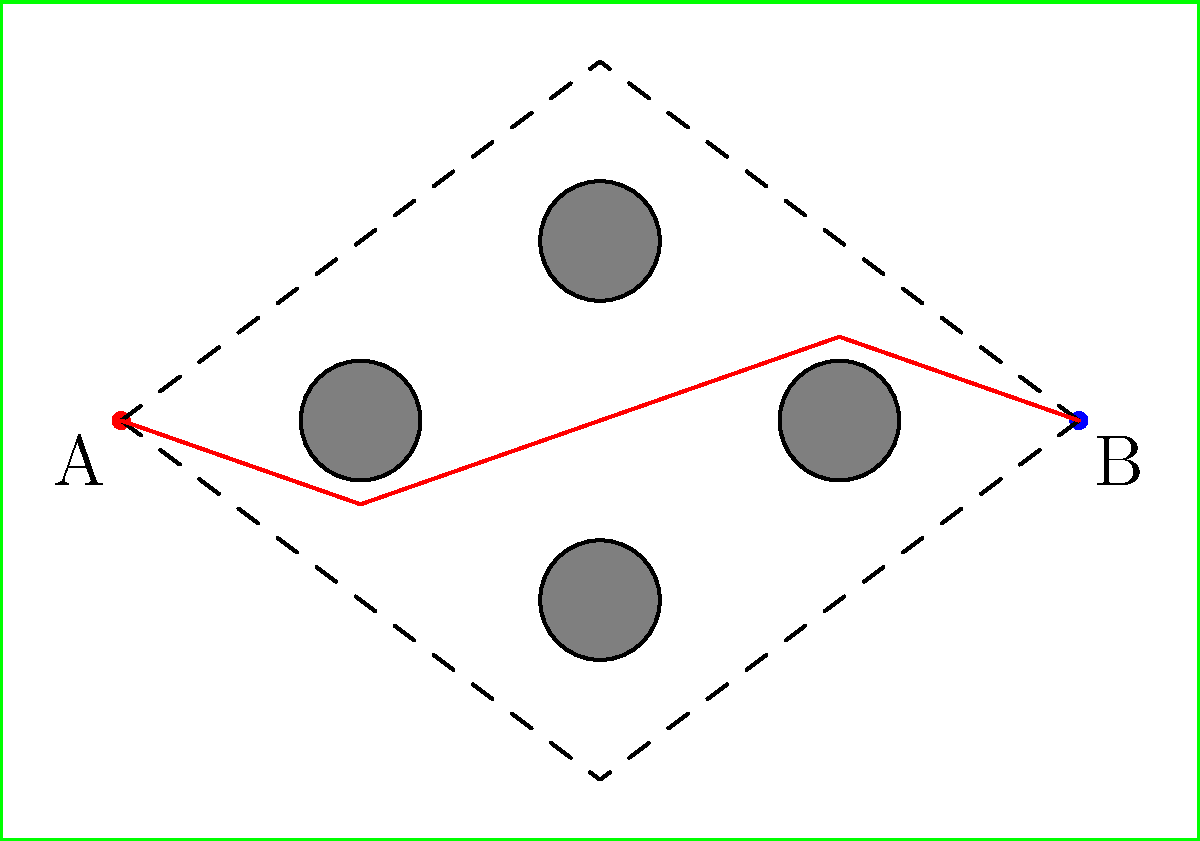On a rugby field, you need to find the shortest path from point A to point B while avoiding defenders positioned as obstacles. Given the diagram, which path represents the optimal route for a fly-half to receive the ball from the scrum-half at point A and reach point B? Calculate the length of this path assuming the field is 100 meters long and 70 meters wide. To solve this problem, we need to follow these steps:

1) Observe the three possible paths shown in the diagram:
   - Lower path (dashed)
   - Upper path (dashed)
   - Middle path (red)

2) The middle path (red) appears to be the shortest as it takes a more direct route while still avoiding the obstacles.

3) To calculate the length of this path, we need to break it down into segments:
   - A to first bend
   - First bend to second bend
   - Second bend to third bend
   - Third bend to B

4) We can use the Pythagorean theorem to calculate each segment length. Let's assume the field is 100 units long and 70 units wide.

5) Segment 1: $\sqrt{20^2 + 7^2} \approx 21.19$ units
   Segment 2: $\sqrt{20^2 + 7^2} \approx 21.19$ units
   Segment 3: $\sqrt{20^2 + 7^2} \approx 21.19$ units
   Segment 4: $\sqrt{20^2 + 7^2} \approx 21.19$ units

6) Total path length: $21.19 * 4 = 84.76$ units

7) Convert to actual field dimensions:
   $84.76 * (100/100) = 84.76$ meters

Therefore, the optimal path for the fly-half is the middle path (red), with a length of approximately 84.76 meters.
Answer: Middle path, 84.76 meters 